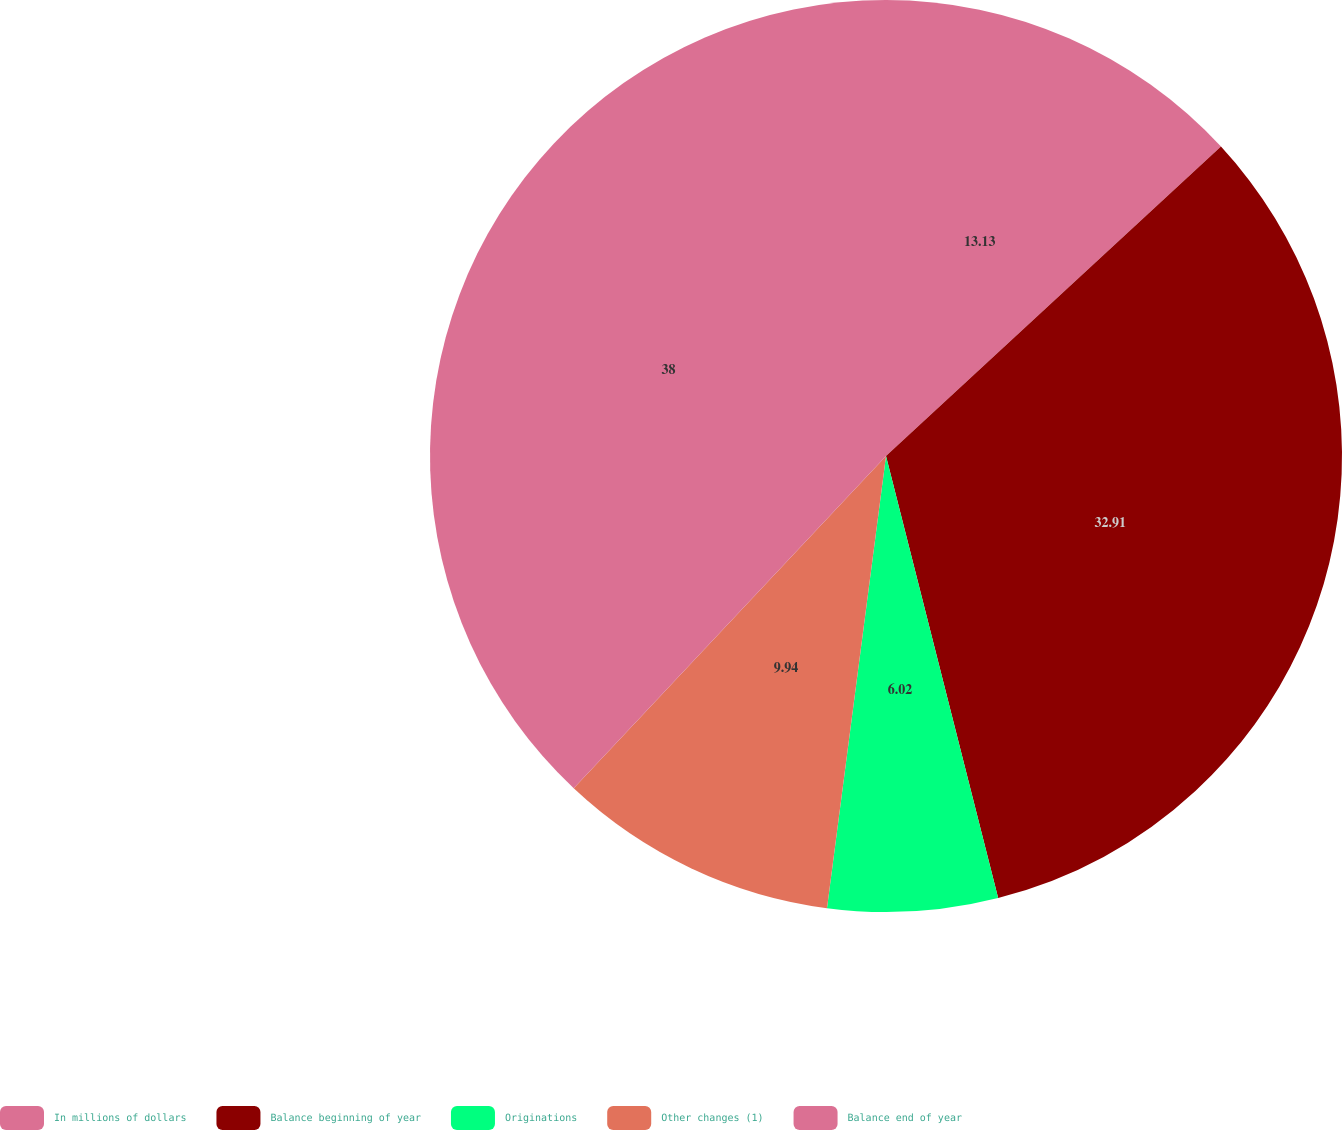Convert chart to OTSL. <chart><loc_0><loc_0><loc_500><loc_500><pie_chart><fcel>In millions of dollars<fcel>Balance beginning of year<fcel>Originations<fcel>Other changes (1)<fcel>Balance end of year<nl><fcel>13.13%<fcel>32.91%<fcel>6.02%<fcel>9.94%<fcel>37.99%<nl></chart> 